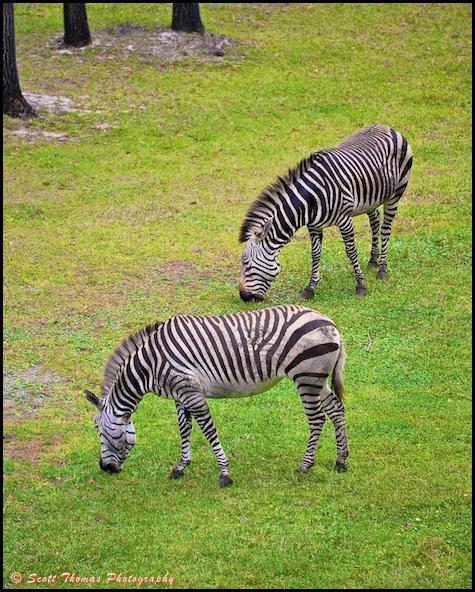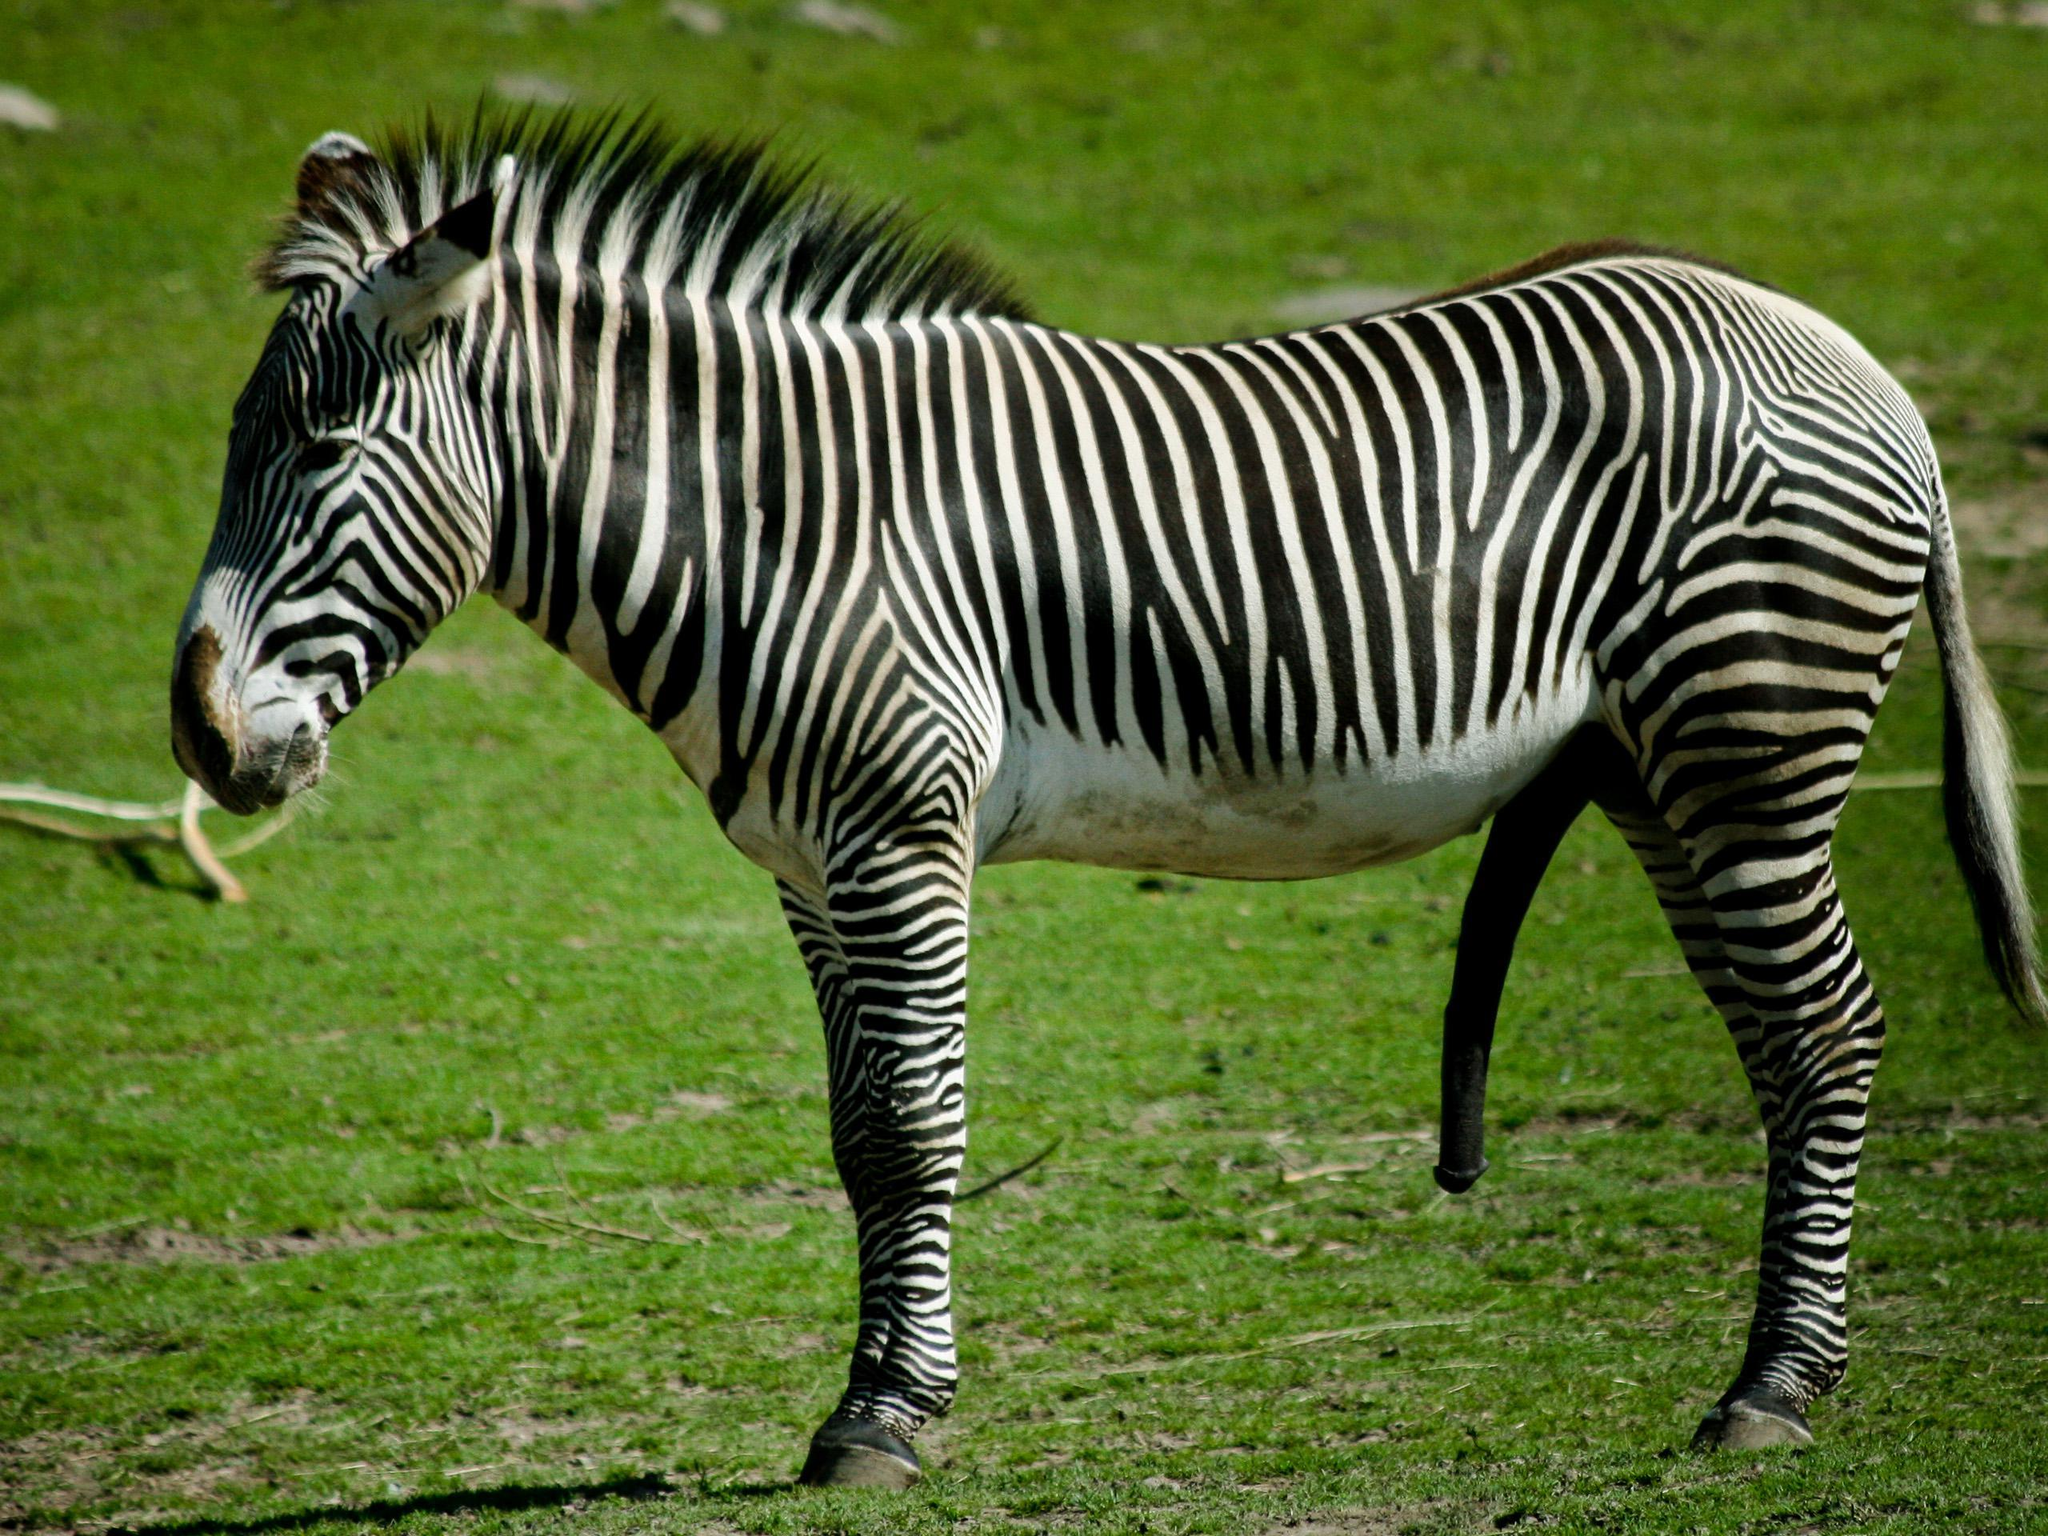The first image is the image on the left, the second image is the image on the right. Assess this claim about the two images: "No more than three zebra are shown in total, and the right image contains a single zebra standing with its head and body in profile.". Correct or not? Answer yes or no. Yes. The first image is the image on the left, the second image is the image on the right. Assess this claim about the two images: "The left image contains exactly two zebras.". Correct or not? Answer yes or no. Yes. 